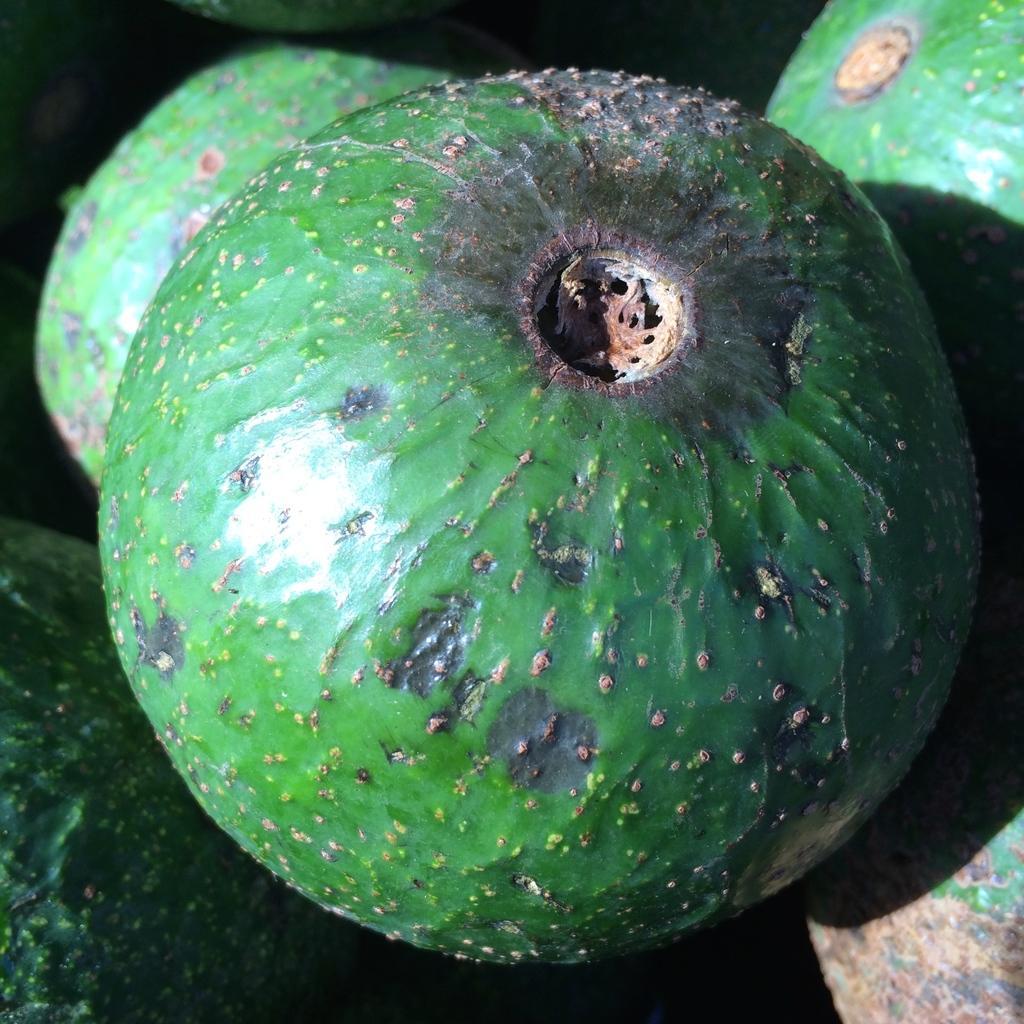In one or two sentences, can you explain what this image depicts? In the center of this picture we can see the green color objects which seems to be the fruits. 